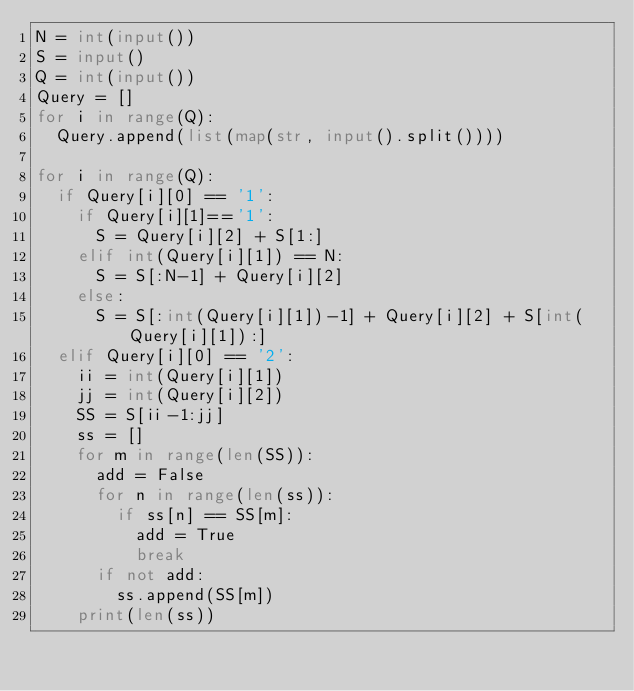Convert code to text. <code><loc_0><loc_0><loc_500><loc_500><_Python_>N = int(input())
S = input()
Q = int(input())
Query = []
for i in range(Q):
  Query.append(list(map(str, input().split())))

for i in range(Q):
  if Query[i][0] == '1':
    if Query[i][1]=='1':
      S = Query[i][2] + S[1:]
    elif int(Query[i][1]) == N:
      S = S[:N-1] + Query[i][2]
    else:
      S = S[:int(Query[i][1])-1] + Query[i][2] + S[int(Query[i][1]):]
  elif Query[i][0] == '2':
    ii = int(Query[i][1])
    jj = int(Query[i][2])
    SS = S[ii-1:jj]
    ss = []
    for m in range(len(SS)):
      add = False
      for n in range(len(ss)):
        if ss[n] == SS[m]:
          add = True
          break
      if not add:
        ss.append(SS[m])
    print(len(ss))
    </code> 